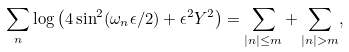Convert formula to latex. <formula><loc_0><loc_0><loc_500><loc_500>\sum _ { n } \log \left ( 4 \sin ^ { 2 } ( \omega _ { n } \epsilon / 2 ) + \epsilon ^ { 2 } Y ^ { 2 } \right ) = \sum _ { | n | \leq m } + \sum _ { | n | > m } ,</formula> 